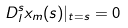Convert formula to latex. <formula><loc_0><loc_0><loc_500><loc_500>D ^ { s } _ { l } x _ { m } ( s ) | _ { t = s } = 0</formula> 